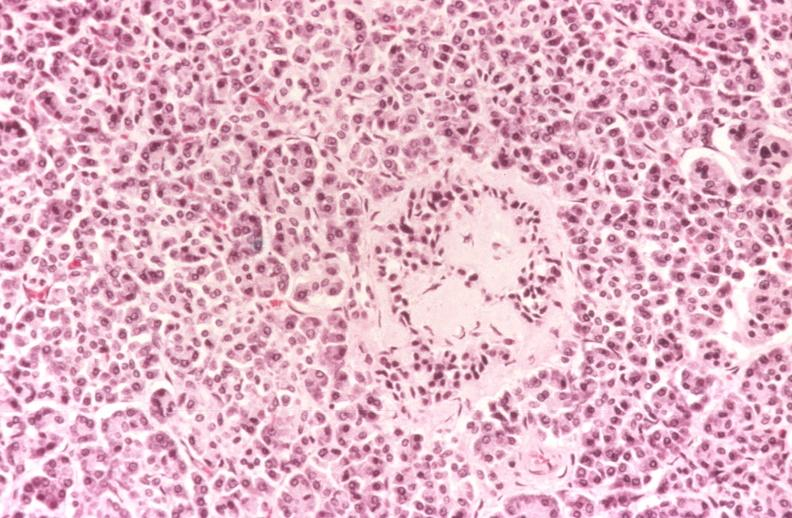where is this?
Answer the question using a single word or phrase. Pancreas 